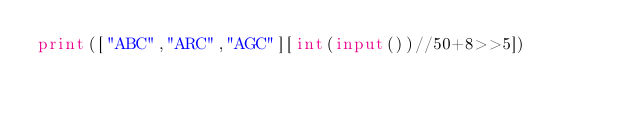<code> <loc_0><loc_0><loc_500><loc_500><_Python_>print(["ABC","ARC","AGC"][int(input())//50+8>>5])</code> 